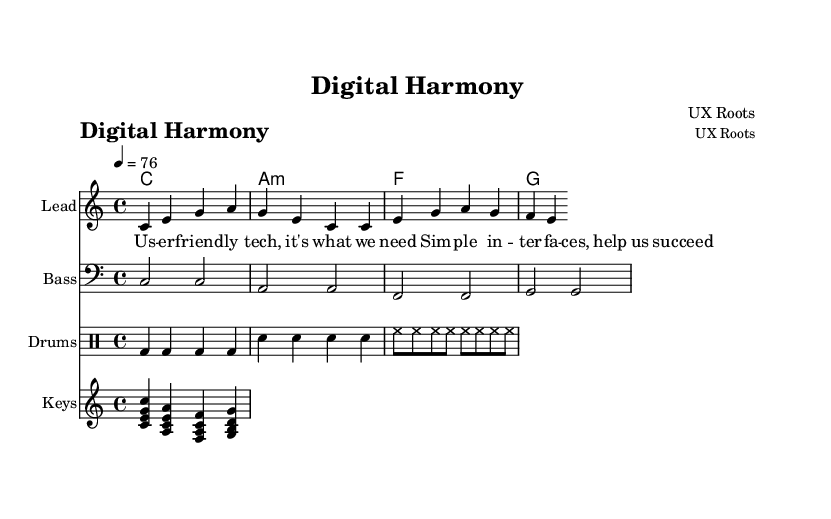What is the key signature of this music? The key signature indicated for this piece is C major, which is shown with no sharps or flats at the beginning of the staff.
Answer: C major What is the time signature of this music? The time signature is 4/4, which is displayed at the beginning of the score and indicates four beats per measure.
Answer: 4/4 What is the tempo marking for this piece? The tempo marking shows "4 = 76," meaning the quarter note should be played at a speed of 76 beats per minute.
Answer: 76 What is the name of the composer? The composer's name is presented in the header of the score as "UX Roots."
Answer: UX Roots How many measures are in the melody section? The melody section has a total of two measures visible in the provided segment of the score. Each measure is indicated visually by the vertical bar lines.
Answer: 2 What type of rhythmic pattern is used in the drum section? The drum section shows a four-beat pattern with bass drums and snare drums primarily, contributing to the characteristic reggae feel with a steady groove.
Answer: Steady groove What is the rhythmic value of the keyboard riff? The keyboard riff consists of quarter notes indicated by the note stems, which can be counted in a regular pulse of the music.
Answer: Quarter notes 